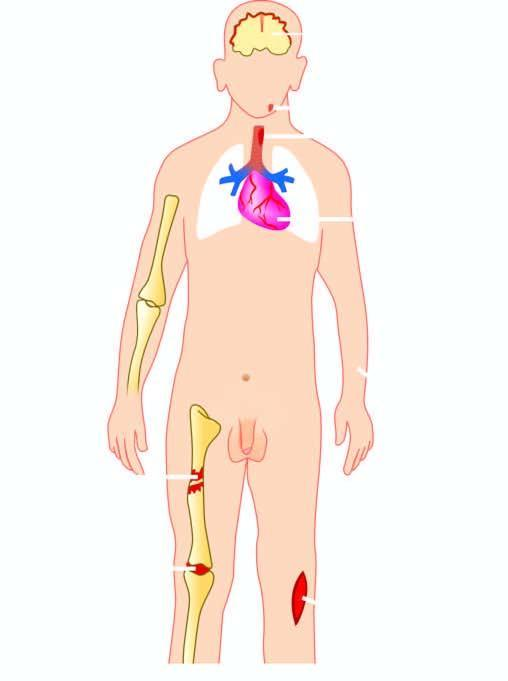s equence of events in the pathogenesis of reversible and irreversible cell injury caused by staphylococcus aureus?
Answer the question using a single word or phrase. No 